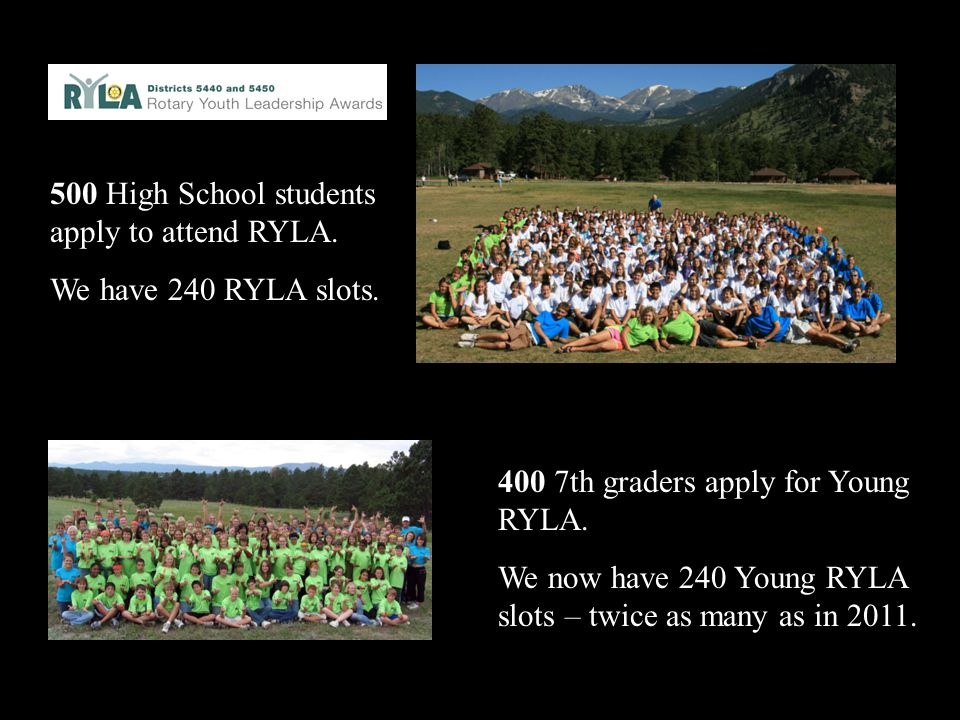Can you describe the scene and atmosphere of the Young RYLA camp shown in the pictures? The scene at the Young RYLA camp depicted in the pictures is lively and vibrant, with a large group of young participants gathered outdoors against the picturesque backdrop of mountains and forests. The campers are dressed in colorful t-shirts, likely designated by groups or teams, adding a cheerful and energetic vibe to the setting. The bright, sunny weather enhances the overall atmosphere, making it look perfect for outdoor activities and team-building exercises. The smiles and casual poses of the participants suggest a friendly, supportive environment focused on learning, leadership, and fun.  How might the natural setting of the camp contribute to the leadership activities? The natural setting of the camp likely plays a significant role in the leadership activities by providing a serene and inspiring backdrop that encourages creativity and personal growth. The mountains and forests create a sense of adventure and exploration, which are key components of many leadership exercises and team-building activities. Nature can also help reduce stress and increase focus, allowing participants to be more engaged and open to learning new skills. Additionally, the beauty and tranquility of the surroundings can foster a sense of community and camaraderie among the participants, enhancing the overall effectiveness of the leadership training. 